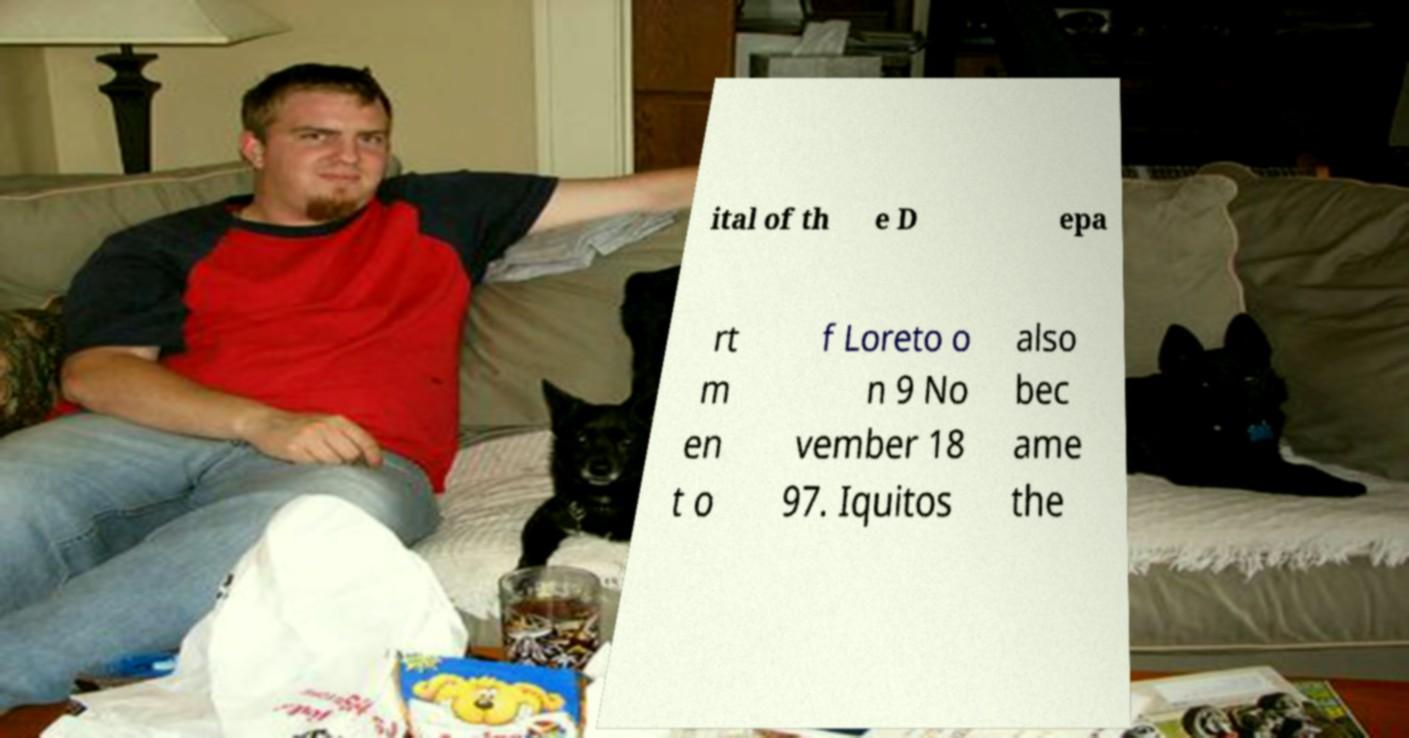Can you accurately transcribe the text from the provided image for me? ital of th e D epa rt m en t o f Loreto o n 9 No vember 18 97. Iquitos also bec ame the 